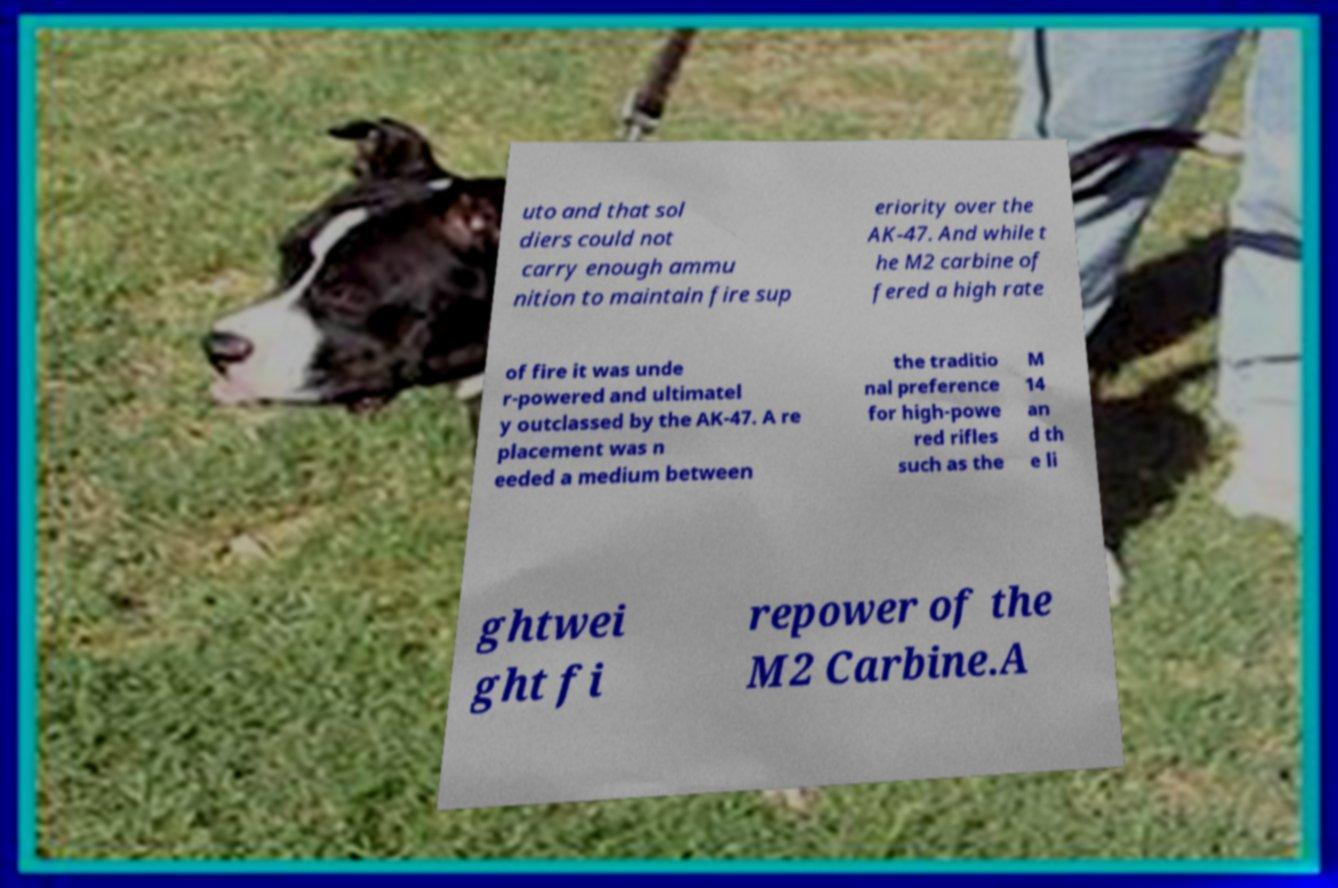Could you extract and type out the text from this image? uto and that sol diers could not carry enough ammu nition to maintain fire sup eriority over the AK-47. And while t he M2 carbine of fered a high rate of fire it was unde r-powered and ultimatel y outclassed by the AK-47. A re placement was n eeded a medium between the traditio nal preference for high-powe red rifles such as the M 14 an d th e li ghtwei ght fi repower of the M2 Carbine.A 